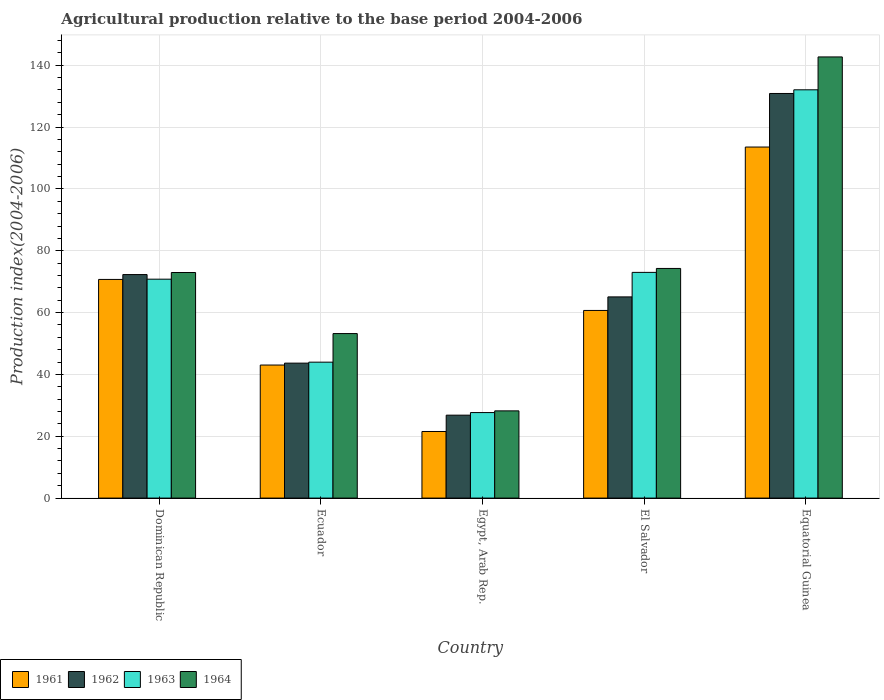How many different coloured bars are there?
Ensure brevity in your answer.  4. Are the number of bars on each tick of the X-axis equal?
Provide a short and direct response. Yes. How many bars are there on the 3rd tick from the left?
Give a very brief answer. 4. What is the label of the 2nd group of bars from the left?
Provide a succinct answer. Ecuador. In how many cases, is the number of bars for a given country not equal to the number of legend labels?
Your answer should be compact. 0. What is the agricultural production index in 1962 in Dominican Republic?
Provide a succinct answer. 72.29. Across all countries, what is the maximum agricultural production index in 1963?
Make the answer very short. 132.05. Across all countries, what is the minimum agricultural production index in 1961?
Your answer should be very brief. 21.54. In which country was the agricultural production index in 1963 maximum?
Offer a very short reply. Equatorial Guinea. In which country was the agricultural production index in 1962 minimum?
Provide a short and direct response. Egypt, Arab Rep. What is the total agricultural production index in 1961 in the graph?
Provide a short and direct response. 309.52. What is the difference between the agricultural production index in 1961 in El Salvador and that in Equatorial Guinea?
Provide a succinct answer. -52.85. What is the difference between the agricultural production index in 1964 in Equatorial Guinea and the agricultural production index in 1963 in Egypt, Arab Rep.?
Your answer should be compact. 115.02. What is the average agricultural production index in 1963 per country?
Offer a very short reply. 69.49. What is the difference between the agricultural production index of/in 1961 and agricultural production index of/in 1962 in Equatorial Guinea?
Keep it short and to the point. -17.32. What is the ratio of the agricultural production index in 1963 in Egypt, Arab Rep. to that in Equatorial Guinea?
Keep it short and to the point. 0.21. What is the difference between the highest and the second highest agricultural production index in 1964?
Your response must be concise. -1.31. What is the difference between the highest and the lowest agricultural production index in 1961?
Offer a terse response. 92. What does the 4th bar from the left in Ecuador represents?
Keep it short and to the point. 1964. What does the 3rd bar from the right in Dominican Republic represents?
Your answer should be very brief. 1962. How many bars are there?
Make the answer very short. 20. What is the difference between two consecutive major ticks on the Y-axis?
Ensure brevity in your answer.  20. Does the graph contain any zero values?
Give a very brief answer. No. Does the graph contain grids?
Offer a very short reply. Yes. Where does the legend appear in the graph?
Provide a short and direct response. Bottom left. How many legend labels are there?
Make the answer very short. 4. What is the title of the graph?
Keep it short and to the point. Agricultural production relative to the base period 2004-2006. What is the label or title of the Y-axis?
Your response must be concise. Production index(2004-2006). What is the Production index(2004-2006) of 1961 in Dominican Republic?
Offer a terse response. 70.72. What is the Production index(2004-2006) in 1962 in Dominican Republic?
Your response must be concise. 72.29. What is the Production index(2004-2006) in 1963 in Dominican Republic?
Offer a very short reply. 70.8. What is the Production index(2004-2006) in 1964 in Dominican Republic?
Your response must be concise. 72.96. What is the Production index(2004-2006) in 1961 in Ecuador?
Your answer should be very brief. 43.03. What is the Production index(2004-2006) of 1962 in Ecuador?
Provide a short and direct response. 43.65. What is the Production index(2004-2006) of 1963 in Ecuador?
Provide a short and direct response. 43.96. What is the Production index(2004-2006) of 1964 in Ecuador?
Offer a terse response. 53.21. What is the Production index(2004-2006) in 1961 in Egypt, Arab Rep.?
Provide a short and direct response. 21.54. What is the Production index(2004-2006) in 1962 in Egypt, Arab Rep.?
Offer a terse response. 26.82. What is the Production index(2004-2006) of 1963 in Egypt, Arab Rep.?
Ensure brevity in your answer.  27.66. What is the Production index(2004-2006) in 1964 in Egypt, Arab Rep.?
Make the answer very short. 28.21. What is the Production index(2004-2006) of 1961 in El Salvador?
Make the answer very short. 60.69. What is the Production index(2004-2006) of 1962 in El Salvador?
Your answer should be very brief. 65.07. What is the Production index(2004-2006) of 1963 in El Salvador?
Keep it short and to the point. 73. What is the Production index(2004-2006) of 1964 in El Salvador?
Your answer should be very brief. 74.27. What is the Production index(2004-2006) in 1961 in Equatorial Guinea?
Offer a very short reply. 113.54. What is the Production index(2004-2006) of 1962 in Equatorial Guinea?
Provide a short and direct response. 130.86. What is the Production index(2004-2006) of 1963 in Equatorial Guinea?
Your answer should be compact. 132.05. What is the Production index(2004-2006) in 1964 in Equatorial Guinea?
Offer a terse response. 142.68. Across all countries, what is the maximum Production index(2004-2006) in 1961?
Keep it short and to the point. 113.54. Across all countries, what is the maximum Production index(2004-2006) of 1962?
Your answer should be very brief. 130.86. Across all countries, what is the maximum Production index(2004-2006) in 1963?
Your answer should be very brief. 132.05. Across all countries, what is the maximum Production index(2004-2006) in 1964?
Provide a short and direct response. 142.68. Across all countries, what is the minimum Production index(2004-2006) of 1961?
Give a very brief answer. 21.54. Across all countries, what is the minimum Production index(2004-2006) in 1962?
Provide a short and direct response. 26.82. Across all countries, what is the minimum Production index(2004-2006) of 1963?
Your answer should be compact. 27.66. Across all countries, what is the minimum Production index(2004-2006) of 1964?
Ensure brevity in your answer.  28.21. What is the total Production index(2004-2006) in 1961 in the graph?
Ensure brevity in your answer.  309.52. What is the total Production index(2004-2006) of 1962 in the graph?
Keep it short and to the point. 338.69. What is the total Production index(2004-2006) in 1963 in the graph?
Your response must be concise. 347.47. What is the total Production index(2004-2006) in 1964 in the graph?
Your answer should be very brief. 371.33. What is the difference between the Production index(2004-2006) of 1961 in Dominican Republic and that in Ecuador?
Offer a terse response. 27.69. What is the difference between the Production index(2004-2006) of 1962 in Dominican Republic and that in Ecuador?
Provide a short and direct response. 28.64. What is the difference between the Production index(2004-2006) in 1963 in Dominican Republic and that in Ecuador?
Keep it short and to the point. 26.84. What is the difference between the Production index(2004-2006) in 1964 in Dominican Republic and that in Ecuador?
Your answer should be very brief. 19.75. What is the difference between the Production index(2004-2006) in 1961 in Dominican Republic and that in Egypt, Arab Rep.?
Provide a short and direct response. 49.18. What is the difference between the Production index(2004-2006) in 1962 in Dominican Republic and that in Egypt, Arab Rep.?
Provide a short and direct response. 45.47. What is the difference between the Production index(2004-2006) in 1963 in Dominican Republic and that in Egypt, Arab Rep.?
Give a very brief answer. 43.14. What is the difference between the Production index(2004-2006) in 1964 in Dominican Republic and that in Egypt, Arab Rep.?
Offer a terse response. 44.75. What is the difference between the Production index(2004-2006) of 1961 in Dominican Republic and that in El Salvador?
Your answer should be compact. 10.03. What is the difference between the Production index(2004-2006) of 1962 in Dominican Republic and that in El Salvador?
Give a very brief answer. 7.22. What is the difference between the Production index(2004-2006) of 1964 in Dominican Republic and that in El Salvador?
Provide a short and direct response. -1.31. What is the difference between the Production index(2004-2006) in 1961 in Dominican Republic and that in Equatorial Guinea?
Give a very brief answer. -42.82. What is the difference between the Production index(2004-2006) of 1962 in Dominican Republic and that in Equatorial Guinea?
Your response must be concise. -58.57. What is the difference between the Production index(2004-2006) in 1963 in Dominican Republic and that in Equatorial Guinea?
Provide a succinct answer. -61.25. What is the difference between the Production index(2004-2006) of 1964 in Dominican Republic and that in Equatorial Guinea?
Give a very brief answer. -69.72. What is the difference between the Production index(2004-2006) of 1961 in Ecuador and that in Egypt, Arab Rep.?
Your response must be concise. 21.49. What is the difference between the Production index(2004-2006) in 1962 in Ecuador and that in Egypt, Arab Rep.?
Keep it short and to the point. 16.83. What is the difference between the Production index(2004-2006) in 1961 in Ecuador and that in El Salvador?
Your answer should be compact. -17.66. What is the difference between the Production index(2004-2006) in 1962 in Ecuador and that in El Salvador?
Provide a short and direct response. -21.42. What is the difference between the Production index(2004-2006) in 1963 in Ecuador and that in El Salvador?
Provide a succinct answer. -29.04. What is the difference between the Production index(2004-2006) of 1964 in Ecuador and that in El Salvador?
Your response must be concise. -21.06. What is the difference between the Production index(2004-2006) in 1961 in Ecuador and that in Equatorial Guinea?
Keep it short and to the point. -70.51. What is the difference between the Production index(2004-2006) of 1962 in Ecuador and that in Equatorial Guinea?
Provide a short and direct response. -87.21. What is the difference between the Production index(2004-2006) of 1963 in Ecuador and that in Equatorial Guinea?
Make the answer very short. -88.09. What is the difference between the Production index(2004-2006) in 1964 in Ecuador and that in Equatorial Guinea?
Your answer should be compact. -89.47. What is the difference between the Production index(2004-2006) in 1961 in Egypt, Arab Rep. and that in El Salvador?
Offer a very short reply. -39.15. What is the difference between the Production index(2004-2006) in 1962 in Egypt, Arab Rep. and that in El Salvador?
Offer a terse response. -38.25. What is the difference between the Production index(2004-2006) in 1963 in Egypt, Arab Rep. and that in El Salvador?
Provide a short and direct response. -45.34. What is the difference between the Production index(2004-2006) of 1964 in Egypt, Arab Rep. and that in El Salvador?
Your answer should be very brief. -46.06. What is the difference between the Production index(2004-2006) of 1961 in Egypt, Arab Rep. and that in Equatorial Guinea?
Give a very brief answer. -92. What is the difference between the Production index(2004-2006) in 1962 in Egypt, Arab Rep. and that in Equatorial Guinea?
Provide a short and direct response. -104.04. What is the difference between the Production index(2004-2006) in 1963 in Egypt, Arab Rep. and that in Equatorial Guinea?
Provide a short and direct response. -104.39. What is the difference between the Production index(2004-2006) in 1964 in Egypt, Arab Rep. and that in Equatorial Guinea?
Your answer should be very brief. -114.47. What is the difference between the Production index(2004-2006) of 1961 in El Salvador and that in Equatorial Guinea?
Keep it short and to the point. -52.85. What is the difference between the Production index(2004-2006) of 1962 in El Salvador and that in Equatorial Guinea?
Make the answer very short. -65.79. What is the difference between the Production index(2004-2006) of 1963 in El Salvador and that in Equatorial Guinea?
Keep it short and to the point. -59.05. What is the difference between the Production index(2004-2006) in 1964 in El Salvador and that in Equatorial Guinea?
Keep it short and to the point. -68.41. What is the difference between the Production index(2004-2006) of 1961 in Dominican Republic and the Production index(2004-2006) of 1962 in Ecuador?
Offer a very short reply. 27.07. What is the difference between the Production index(2004-2006) in 1961 in Dominican Republic and the Production index(2004-2006) in 1963 in Ecuador?
Your response must be concise. 26.76. What is the difference between the Production index(2004-2006) in 1961 in Dominican Republic and the Production index(2004-2006) in 1964 in Ecuador?
Make the answer very short. 17.51. What is the difference between the Production index(2004-2006) of 1962 in Dominican Republic and the Production index(2004-2006) of 1963 in Ecuador?
Your answer should be very brief. 28.33. What is the difference between the Production index(2004-2006) of 1962 in Dominican Republic and the Production index(2004-2006) of 1964 in Ecuador?
Give a very brief answer. 19.08. What is the difference between the Production index(2004-2006) of 1963 in Dominican Republic and the Production index(2004-2006) of 1964 in Ecuador?
Your response must be concise. 17.59. What is the difference between the Production index(2004-2006) of 1961 in Dominican Republic and the Production index(2004-2006) of 1962 in Egypt, Arab Rep.?
Your answer should be compact. 43.9. What is the difference between the Production index(2004-2006) of 1961 in Dominican Republic and the Production index(2004-2006) of 1963 in Egypt, Arab Rep.?
Offer a very short reply. 43.06. What is the difference between the Production index(2004-2006) in 1961 in Dominican Republic and the Production index(2004-2006) in 1964 in Egypt, Arab Rep.?
Keep it short and to the point. 42.51. What is the difference between the Production index(2004-2006) in 1962 in Dominican Republic and the Production index(2004-2006) in 1963 in Egypt, Arab Rep.?
Give a very brief answer. 44.63. What is the difference between the Production index(2004-2006) in 1962 in Dominican Republic and the Production index(2004-2006) in 1964 in Egypt, Arab Rep.?
Your answer should be compact. 44.08. What is the difference between the Production index(2004-2006) of 1963 in Dominican Republic and the Production index(2004-2006) of 1964 in Egypt, Arab Rep.?
Your answer should be very brief. 42.59. What is the difference between the Production index(2004-2006) in 1961 in Dominican Republic and the Production index(2004-2006) in 1962 in El Salvador?
Provide a succinct answer. 5.65. What is the difference between the Production index(2004-2006) in 1961 in Dominican Republic and the Production index(2004-2006) in 1963 in El Salvador?
Provide a succinct answer. -2.28. What is the difference between the Production index(2004-2006) in 1961 in Dominican Republic and the Production index(2004-2006) in 1964 in El Salvador?
Give a very brief answer. -3.55. What is the difference between the Production index(2004-2006) of 1962 in Dominican Republic and the Production index(2004-2006) of 1963 in El Salvador?
Give a very brief answer. -0.71. What is the difference between the Production index(2004-2006) of 1962 in Dominican Republic and the Production index(2004-2006) of 1964 in El Salvador?
Give a very brief answer. -1.98. What is the difference between the Production index(2004-2006) of 1963 in Dominican Republic and the Production index(2004-2006) of 1964 in El Salvador?
Give a very brief answer. -3.47. What is the difference between the Production index(2004-2006) in 1961 in Dominican Republic and the Production index(2004-2006) in 1962 in Equatorial Guinea?
Make the answer very short. -60.14. What is the difference between the Production index(2004-2006) of 1961 in Dominican Republic and the Production index(2004-2006) of 1963 in Equatorial Guinea?
Offer a very short reply. -61.33. What is the difference between the Production index(2004-2006) of 1961 in Dominican Republic and the Production index(2004-2006) of 1964 in Equatorial Guinea?
Make the answer very short. -71.96. What is the difference between the Production index(2004-2006) of 1962 in Dominican Republic and the Production index(2004-2006) of 1963 in Equatorial Guinea?
Provide a short and direct response. -59.76. What is the difference between the Production index(2004-2006) of 1962 in Dominican Republic and the Production index(2004-2006) of 1964 in Equatorial Guinea?
Provide a succinct answer. -70.39. What is the difference between the Production index(2004-2006) of 1963 in Dominican Republic and the Production index(2004-2006) of 1964 in Equatorial Guinea?
Ensure brevity in your answer.  -71.88. What is the difference between the Production index(2004-2006) in 1961 in Ecuador and the Production index(2004-2006) in 1962 in Egypt, Arab Rep.?
Provide a succinct answer. 16.21. What is the difference between the Production index(2004-2006) of 1961 in Ecuador and the Production index(2004-2006) of 1963 in Egypt, Arab Rep.?
Your response must be concise. 15.37. What is the difference between the Production index(2004-2006) in 1961 in Ecuador and the Production index(2004-2006) in 1964 in Egypt, Arab Rep.?
Offer a terse response. 14.82. What is the difference between the Production index(2004-2006) of 1962 in Ecuador and the Production index(2004-2006) of 1963 in Egypt, Arab Rep.?
Ensure brevity in your answer.  15.99. What is the difference between the Production index(2004-2006) of 1962 in Ecuador and the Production index(2004-2006) of 1964 in Egypt, Arab Rep.?
Offer a terse response. 15.44. What is the difference between the Production index(2004-2006) in 1963 in Ecuador and the Production index(2004-2006) in 1964 in Egypt, Arab Rep.?
Your answer should be very brief. 15.75. What is the difference between the Production index(2004-2006) of 1961 in Ecuador and the Production index(2004-2006) of 1962 in El Salvador?
Provide a succinct answer. -22.04. What is the difference between the Production index(2004-2006) in 1961 in Ecuador and the Production index(2004-2006) in 1963 in El Salvador?
Offer a very short reply. -29.97. What is the difference between the Production index(2004-2006) in 1961 in Ecuador and the Production index(2004-2006) in 1964 in El Salvador?
Give a very brief answer. -31.24. What is the difference between the Production index(2004-2006) in 1962 in Ecuador and the Production index(2004-2006) in 1963 in El Salvador?
Offer a very short reply. -29.35. What is the difference between the Production index(2004-2006) in 1962 in Ecuador and the Production index(2004-2006) in 1964 in El Salvador?
Your answer should be compact. -30.62. What is the difference between the Production index(2004-2006) of 1963 in Ecuador and the Production index(2004-2006) of 1964 in El Salvador?
Make the answer very short. -30.31. What is the difference between the Production index(2004-2006) of 1961 in Ecuador and the Production index(2004-2006) of 1962 in Equatorial Guinea?
Your answer should be compact. -87.83. What is the difference between the Production index(2004-2006) in 1961 in Ecuador and the Production index(2004-2006) in 1963 in Equatorial Guinea?
Offer a terse response. -89.02. What is the difference between the Production index(2004-2006) of 1961 in Ecuador and the Production index(2004-2006) of 1964 in Equatorial Guinea?
Give a very brief answer. -99.65. What is the difference between the Production index(2004-2006) in 1962 in Ecuador and the Production index(2004-2006) in 1963 in Equatorial Guinea?
Your answer should be compact. -88.4. What is the difference between the Production index(2004-2006) of 1962 in Ecuador and the Production index(2004-2006) of 1964 in Equatorial Guinea?
Keep it short and to the point. -99.03. What is the difference between the Production index(2004-2006) in 1963 in Ecuador and the Production index(2004-2006) in 1964 in Equatorial Guinea?
Offer a terse response. -98.72. What is the difference between the Production index(2004-2006) in 1961 in Egypt, Arab Rep. and the Production index(2004-2006) in 1962 in El Salvador?
Give a very brief answer. -43.53. What is the difference between the Production index(2004-2006) of 1961 in Egypt, Arab Rep. and the Production index(2004-2006) of 1963 in El Salvador?
Keep it short and to the point. -51.46. What is the difference between the Production index(2004-2006) of 1961 in Egypt, Arab Rep. and the Production index(2004-2006) of 1964 in El Salvador?
Provide a succinct answer. -52.73. What is the difference between the Production index(2004-2006) of 1962 in Egypt, Arab Rep. and the Production index(2004-2006) of 1963 in El Salvador?
Provide a succinct answer. -46.18. What is the difference between the Production index(2004-2006) in 1962 in Egypt, Arab Rep. and the Production index(2004-2006) in 1964 in El Salvador?
Offer a terse response. -47.45. What is the difference between the Production index(2004-2006) of 1963 in Egypt, Arab Rep. and the Production index(2004-2006) of 1964 in El Salvador?
Your response must be concise. -46.61. What is the difference between the Production index(2004-2006) of 1961 in Egypt, Arab Rep. and the Production index(2004-2006) of 1962 in Equatorial Guinea?
Ensure brevity in your answer.  -109.32. What is the difference between the Production index(2004-2006) in 1961 in Egypt, Arab Rep. and the Production index(2004-2006) in 1963 in Equatorial Guinea?
Your answer should be very brief. -110.51. What is the difference between the Production index(2004-2006) in 1961 in Egypt, Arab Rep. and the Production index(2004-2006) in 1964 in Equatorial Guinea?
Keep it short and to the point. -121.14. What is the difference between the Production index(2004-2006) of 1962 in Egypt, Arab Rep. and the Production index(2004-2006) of 1963 in Equatorial Guinea?
Offer a very short reply. -105.23. What is the difference between the Production index(2004-2006) in 1962 in Egypt, Arab Rep. and the Production index(2004-2006) in 1964 in Equatorial Guinea?
Offer a very short reply. -115.86. What is the difference between the Production index(2004-2006) of 1963 in Egypt, Arab Rep. and the Production index(2004-2006) of 1964 in Equatorial Guinea?
Provide a short and direct response. -115.02. What is the difference between the Production index(2004-2006) in 1961 in El Salvador and the Production index(2004-2006) in 1962 in Equatorial Guinea?
Provide a succinct answer. -70.17. What is the difference between the Production index(2004-2006) in 1961 in El Salvador and the Production index(2004-2006) in 1963 in Equatorial Guinea?
Your response must be concise. -71.36. What is the difference between the Production index(2004-2006) in 1961 in El Salvador and the Production index(2004-2006) in 1964 in Equatorial Guinea?
Provide a succinct answer. -81.99. What is the difference between the Production index(2004-2006) in 1962 in El Salvador and the Production index(2004-2006) in 1963 in Equatorial Guinea?
Offer a terse response. -66.98. What is the difference between the Production index(2004-2006) in 1962 in El Salvador and the Production index(2004-2006) in 1964 in Equatorial Guinea?
Ensure brevity in your answer.  -77.61. What is the difference between the Production index(2004-2006) in 1963 in El Salvador and the Production index(2004-2006) in 1964 in Equatorial Guinea?
Offer a very short reply. -69.68. What is the average Production index(2004-2006) in 1961 per country?
Your answer should be compact. 61.9. What is the average Production index(2004-2006) of 1962 per country?
Offer a terse response. 67.74. What is the average Production index(2004-2006) of 1963 per country?
Give a very brief answer. 69.49. What is the average Production index(2004-2006) in 1964 per country?
Offer a very short reply. 74.27. What is the difference between the Production index(2004-2006) of 1961 and Production index(2004-2006) of 1962 in Dominican Republic?
Make the answer very short. -1.57. What is the difference between the Production index(2004-2006) in 1961 and Production index(2004-2006) in 1963 in Dominican Republic?
Offer a very short reply. -0.08. What is the difference between the Production index(2004-2006) in 1961 and Production index(2004-2006) in 1964 in Dominican Republic?
Your response must be concise. -2.24. What is the difference between the Production index(2004-2006) of 1962 and Production index(2004-2006) of 1963 in Dominican Republic?
Provide a short and direct response. 1.49. What is the difference between the Production index(2004-2006) in 1962 and Production index(2004-2006) in 1964 in Dominican Republic?
Offer a terse response. -0.67. What is the difference between the Production index(2004-2006) of 1963 and Production index(2004-2006) of 1964 in Dominican Republic?
Give a very brief answer. -2.16. What is the difference between the Production index(2004-2006) in 1961 and Production index(2004-2006) in 1962 in Ecuador?
Make the answer very short. -0.62. What is the difference between the Production index(2004-2006) in 1961 and Production index(2004-2006) in 1963 in Ecuador?
Offer a very short reply. -0.93. What is the difference between the Production index(2004-2006) in 1961 and Production index(2004-2006) in 1964 in Ecuador?
Your response must be concise. -10.18. What is the difference between the Production index(2004-2006) of 1962 and Production index(2004-2006) of 1963 in Ecuador?
Provide a succinct answer. -0.31. What is the difference between the Production index(2004-2006) of 1962 and Production index(2004-2006) of 1964 in Ecuador?
Make the answer very short. -9.56. What is the difference between the Production index(2004-2006) of 1963 and Production index(2004-2006) of 1964 in Ecuador?
Give a very brief answer. -9.25. What is the difference between the Production index(2004-2006) in 1961 and Production index(2004-2006) in 1962 in Egypt, Arab Rep.?
Make the answer very short. -5.28. What is the difference between the Production index(2004-2006) of 1961 and Production index(2004-2006) of 1963 in Egypt, Arab Rep.?
Your response must be concise. -6.12. What is the difference between the Production index(2004-2006) of 1961 and Production index(2004-2006) of 1964 in Egypt, Arab Rep.?
Ensure brevity in your answer.  -6.67. What is the difference between the Production index(2004-2006) in 1962 and Production index(2004-2006) in 1963 in Egypt, Arab Rep.?
Your response must be concise. -0.84. What is the difference between the Production index(2004-2006) in 1962 and Production index(2004-2006) in 1964 in Egypt, Arab Rep.?
Offer a very short reply. -1.39. What is the difference between the Production index(2004-2006) in 1963 and Production index(2004-2006) in 1964 in Egypt, Arab Rep.?
Make the answer very short. -0.55. What is the difference between the Production index(2004-2006) of 1961 and Production index(2004-2006) of 1962 in El Salvador?
Keep it short and to the point. -4.38. What is the difference between the Production index(2004-2006) in 1961 and Production index(2004-2006) in 1963 in El Salvador?
Your answer should be compact. -12.31. What is the difference between the Production index(2004-2006) of 1961 and Production index(2004-2006) of 1964 in El Salvador?
Ensure brevity in your answer.  -13.58. What is the difference between the Production index(2004-2006) in 1962 and Production index(2004-2006) in 1963 in El Salvador?
Give a very brief answer. -7.93. What is the difference between the Production index(2004-2006) of 1962 and Production index(2004-2006) of 1964 in El Salvador?
Provide a short and direct response. -9.2. What is the difference between the Production index(2004-2006) of 1963 and Production index(2004-2006) of 1964 in El Salvador?
Keep it short and to the point. -1.27. What is the difference between the Production index(2004-2006) in 1961 and Production index(2004-2006) in 1962 in Equatorial Guinea?
Offer a terse response. -17.32. What is the difference between the Production index(2004-2006) of 1961 and Production index(2004-2006) of 1963 in Equatorial Guinea?
Your response must be concise. -18.51. What is the difference between the Production index(2004-2006) in 1961 and Production index(2004-2006) in 1964 in Equatorial Guinea?
Keep it short and to the point. -29.14. What is the difference between the Production index(2004-2006) of 1962 and Production index(2004-2006) of 1963 in Equatorial Guinea?
Your response must be concise. -1.19. What is the difference between the Production index(2004-2006) of 1962 and Production index(2004-2006) of 1964 in Equatorial Guinea?
Your response must be concise. -11.82. What is the difference between the Production index(2004-2006) in 1963 and Production index(2004-2006) in 1964 in Equatorial Guinea?
Your response must be concise. -10.63. What is the ratio of the Production index(2004-2006) of 1961 in Dominican Republic to that in Ecuador?
Ensure brevity in your answer.  1.64. What is the ratio of the Production index(2004-2006) of 1962 in Dominican Republic to that in Ecuador?
Your response must be concise. 1.66. What is the ratio of the Production index(2004-2006) of 1963 in Dominican Republic to that in Ecuador?
Keep it short and to the point. 1.61. What is the ratio of the Production index(2004-2006) in 1964 in Dominican Republic to that in Ecuador?
Make the answer very short. 1.37. What is the ratio of the Production index(2004-2006) in 1961 in Dominican Republic to that in Egypt, Arab Rep.?
Ensure brevity in your answer.  3.28. What is the ratio of the Production index(2004-2006) in 1962 in Dominican Republic to that in Egypt, Arab Rep.?
Give a very brief answer. 2.7. What is the ratio of the Production index(2004-2006) in 1963 in Dominican Republic to that in Egypt, Arab Rep.?
Keep it short and to the point. 2.56. What is the ratio of the Production index(2004-2006) in 1964 in Dominican Republic to that in Egypt, Arab Rep.?
Provide a succinct answer. 2.59. What is the ratio of the Production index(2004-2006) of 1961 in Dominican Republic to that in El Salvador?
Keep it short and to the point. 1.17. What is the ratio of the Production index(2004-2006) of 1962 in Dominican Republic to that in El Salvador?
Your answer should be compact. 1.11. What is the ratio of the Production index(2004-2006) in 1963 in Dominican Republic to that in El Salvador?
Make the answer very short. 0.97. What is the ratio of the Production index(2004-2006) of 1964 in Dominican Republic to that in El Salvador?
Ensure brevity in your answer.  0.98. What is the ratio of the Production index(2004-2006) in 1961 in Dominican Republic to that in Equatorial Guinea?
Your answer should be very brief. 0.62. What is the ratio of the Production index(2004-2006) in 1962 in Dominican Republic to that in Equatorial Guinea?
Give a very brief answer. 0.55. What is the ratio of the Production index(2004-2006) of 1963 in Dominican Republic to that in Equatorial Guinea?
Ensure brevity in your answer.  0.54. What is the ratio of the Production index(2004-2006) of 1964 in Dominican Republic to that in Equatorial Guinea?
Your answer should be compact. 0.51. What is the ratio of the Production index(2004-2006) of 1961 in Ecuador to that in Egypt, Arab Rep.?
Give a very brief answer. 2. What is the ratio of the Production index(2004-2006) in 1962 in Ecuador to that in Egypt, Arab Rep.?
Ensure brevity in your answer.  1.63. What is the ratio of the Production index(2004-2006) in 1963 in Ecuador to that in Egypt, Arab Rep.?
Your answer should be compact. 1.59. What is the ratio of the Production index(2004-2006) in 1964 in Ecuador to that in Egypt, Arab Rep.?
Your response must be concise. 1.89. What is the ratio of the Production index(2004-2006) of 1961 in Ecuador to that in El Salvador?
Provide a succinct answer. 0.71. What is the ratio of the Production index(2004-2006) of 1962 in Ecuador to that in El Salvador?
Your answer should be very brief. 0.67. What is the ratio of the Production index(2004-2006) in 1963 in Ecuador to that in El Salvador?
Provide a short and direct response. 0.6. What is the ratio of the Production index(2004-2006) in 1964 in Ecuador to that in El Salvador?
Keep it short and to the point. 0.72. What is the ratio of the Production index(2004-2006) in 1961 in Ecuador to that in Equatorial Guinea?
Your answer should be compact. 0.38. What is the ratio of the Production index(2004-2006) in 1962 in Ecuador to that in Equatorial Guinea?
Offer a terse response. 0.33. What is the ratio of the Production index(2004-2006) of 1963 in Ecuador to that in Equatorial Guinea?
Ensure brevity in your answer.  0.33. What is the ratio of the Production index(2004-2006) in 1964 in Ecuador to that in Equatorial Guinea?
Offer a very short reply. 0.37. What is the ratio of the Production index(2004-2006) of 1961 in Egypt, Arab Rep. to that in El Salvador?
Provide a succinct answer. 0.35. What is the ratio of the Production index(2004-2006) in 1962 in Egypt, Arab Rep. to that in El Salvador?
Keep it short and to the point. 0.41. What is the ratio of the Production index(2004-2006) of 1963 in Egypt, Arab Rep. to that in El Salvador?
Your answer should be very brief. 0.38. What is the ratio of the Production index(2004-2006) in 1964 in Egypt, Arab Rep. to that in El Salvador?
Offer a very short reply. 0.38. What is the ratio of the Production index(2004-2006) in 1961 in Egypt, Arab Rep. to that in Equatorial Guinea?
Provide a short and direct response. 0.19. What is the ratio of the Production index(2004-2006) in 1962 in Egypt, Arab Rep. to that in Equatorial Guinea?
Your response must be concise. 0.2. What is the ratio of the Production index(2004-2006) of 1963 in Egypt, Arab Rep. to that in Equatorial Guinea?
Provide a succinct answer. 0.21. What is the ratio of the Production index(2004-2006) of 1964 in Egypt, Arab Rep. to that in Equatorial Guinea?
Your response must be concise. 0.2. What is the ratio of the Production index(2004-2006) of 1961 in El Salvador to that in Equatorial Guinea?
Your answer should be very brief. 0.53. What is the ratio of the Production index(2004-2006) of 1962 in El Salvador to that in Equatorial Guinea?
Offer a very short reply. 0.5. What is the ratio of the Production index(2004-2006) in 1963 in El Salvador to that in Equatorial Guinea?
Provide a succinct answer. 0.55. What is the ratio of the Production index(2004-2006) in 1964 in El Salvador to that in Equatorial Guinea?
Offer a very short reply. 0.52. What is the difference between the highest and the second highest Production index(2004-2006) in 1961?
Your response must be concise. 42.82. What is the difference between the highest and the second highest Production index(2004-2006) in 1962?
Your answer should be very brief. 58.57. What is the difference between the highest and the second highest Production index(2004-2006) of 1963?
Give a very brief answer. 59.05. What is the difference between the highest and the second highest Production index(2004-2006) in 1964?
Ensure brevity in your answer.  68.41. What is the difference between the highest and the lowest Production index(2004-2006) of 1961?
Provide a succinct answer. 92. What is the difference between the highest and the lowest Production index(2004-2006) in 1962?
Your response must be concise. 104.04. What is the difference between the highest and the lowest Production index(2004-2006) of 1963?
Give a very brief answer. 104.39. What is the difference between the highest and the lowest Production index(2004-2006) of 1964?
Make the answer very short. 114.47. 